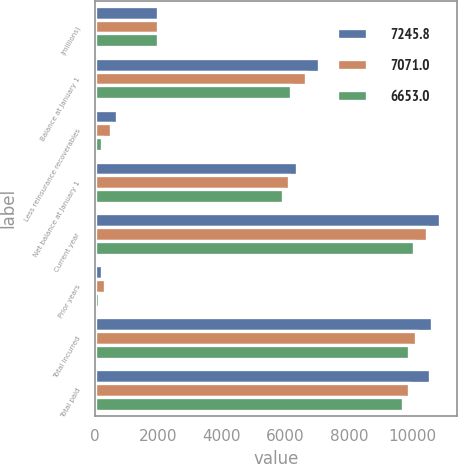Convert chart to OTSL. <chart><loc_0><loc_0><loc_500><loc_500><stacked_bar_chart><ecel><fcel>(millions)<fcel>Balance at January 1<fcel>Less reinsurance recoverables<fcel>Net balance at January 1<fcel>Current year<fcel>Prior years<fcel>Total incurred<fcel>Total paid<nl><fcel>7245.8<fcel>2011<fcel>7071<fcel>704.1<fcel>6366.9<fcel>10876.8<fcel>242<fcel>10634.8<fcel>10541.6<nl><fcel>7071<fcel>2010<fcel>6653<fcel>529.4<fcel>6123.6<fcel>10451.7<fcel>320.4<fcel>10131.3<fcel>9888<nl><fcel>6653<fcel>2009<fcel>6177.4<fcel>244.5<fcel>5932.9<fcel>10040.9<fcel>136<fcel>9904.9<fcel>9714.2<nl></chart> 